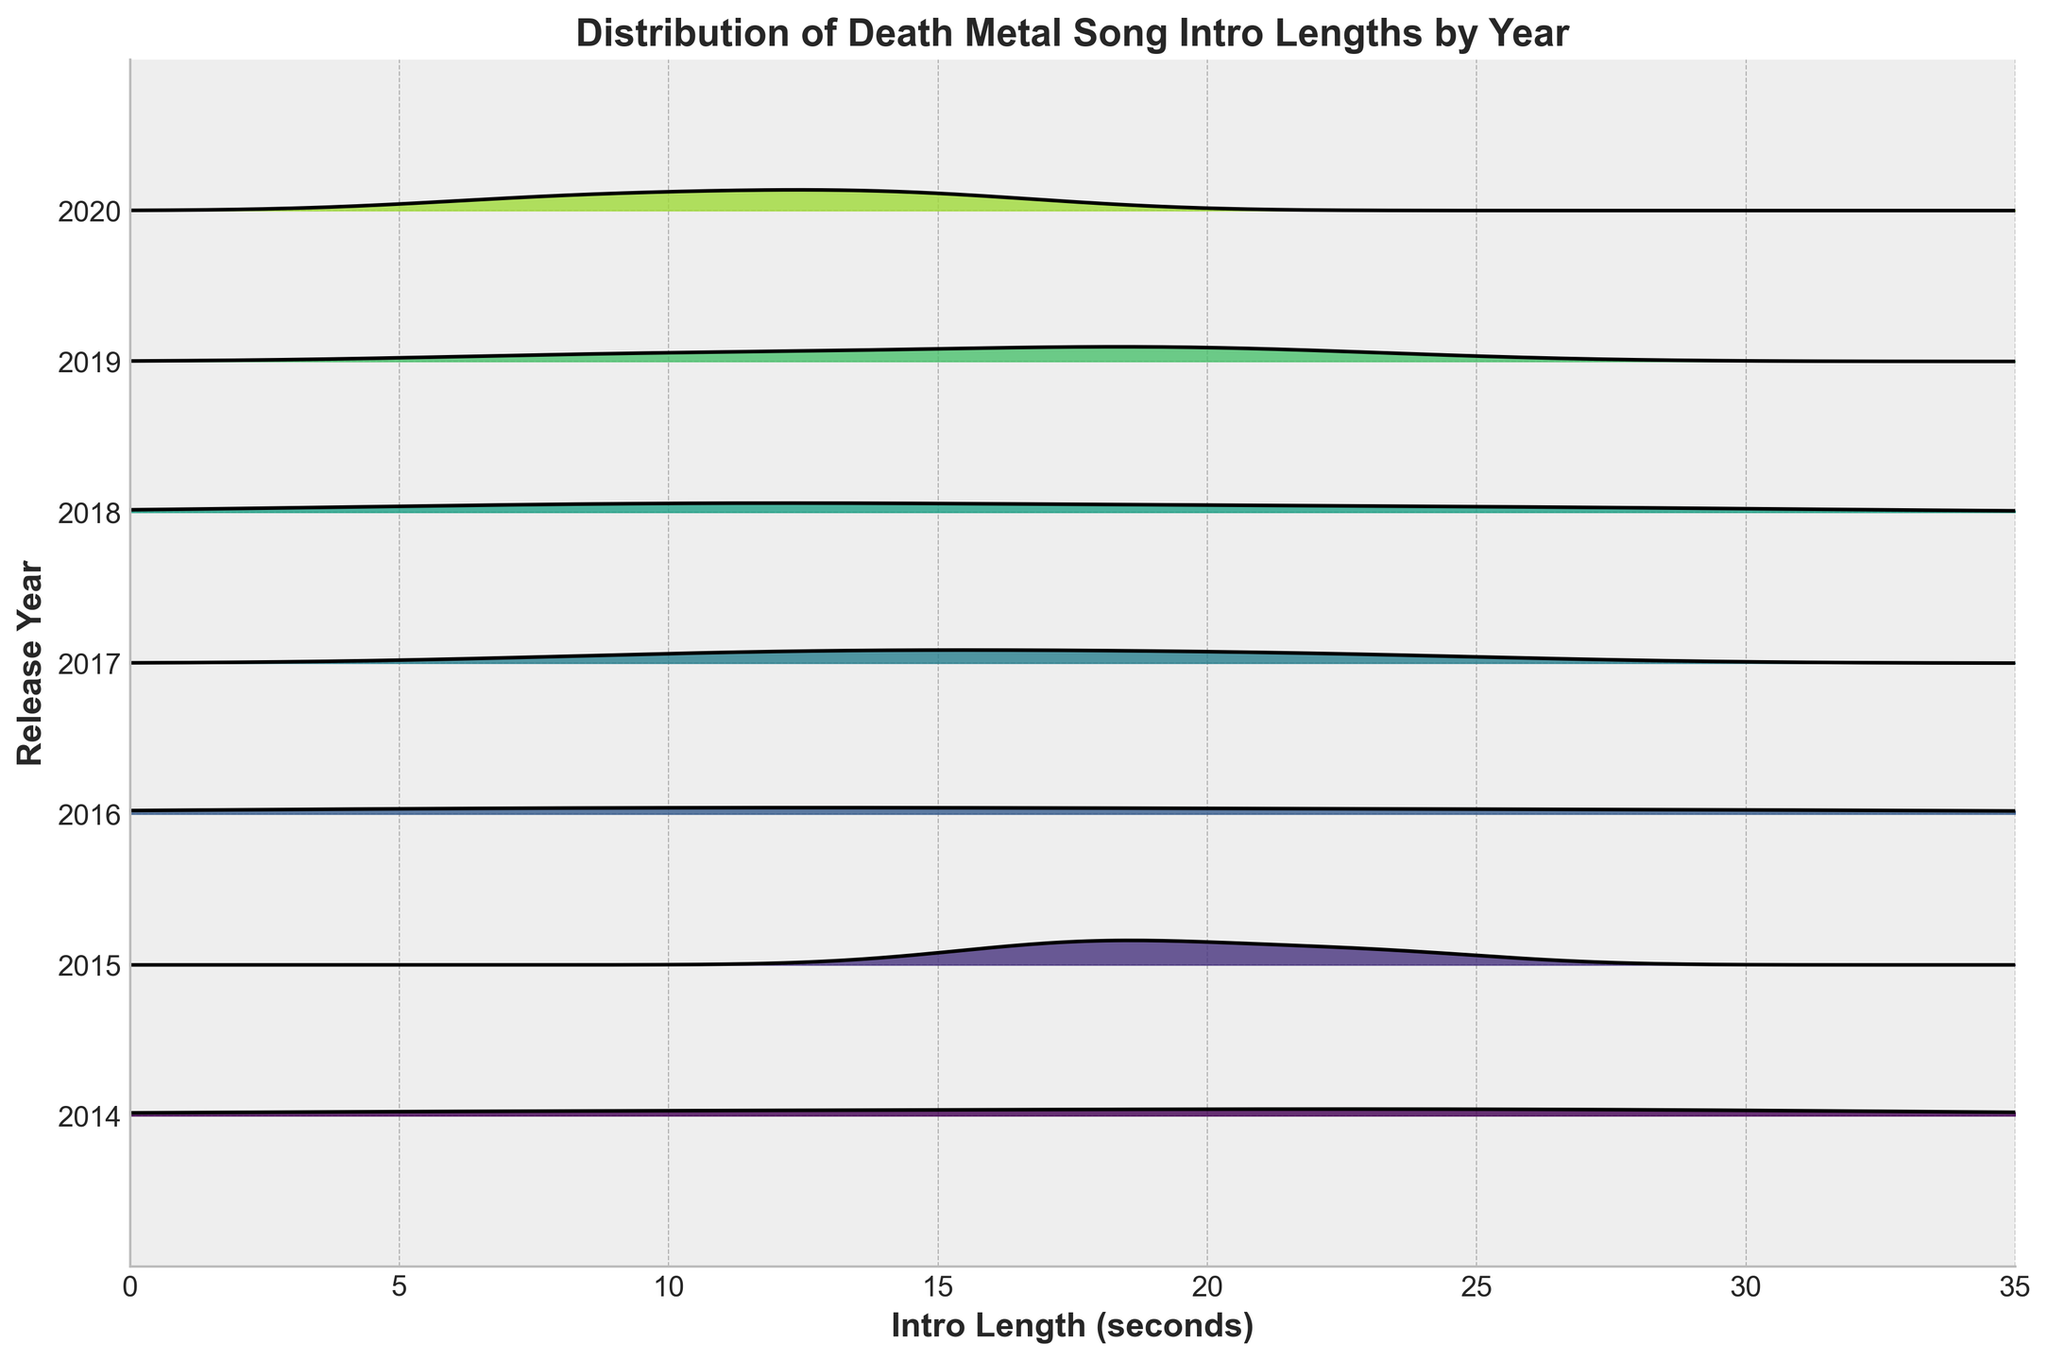What is the overall trend in intro lengths over the years? By examining the distribution for each year moving from 2014 to 2020, we can see if there is a tendency for intros to become longer or shorter. In 2016, for example, there seems to be a peak around 30 seconds, which is higher than the peaks in 2014 and 2015. However, the peaks in 2019 and 2020 seem to be lower, indicating shorter intros.
Answer: The overall trend shows fluctuation with no clear linear increase or decrease Which year had the longest song intro and what is its length? Looking at the peaks of each distribution, the year 2016 has the longest intro peak with a value of around 30 seconds.
Answer: 2016, 30 seconds Which years have the most and least varied intro lengths? Variation can be inferred by looking at the spread of the KDE curves. A wider and flatter curve suggests more variation. For instance, 2016 appears to have a wide spread, while 2020 shows a narrower one.
Answer: 2016 has the most varied and 2020 has the least varied Are there any years where intro lengths appear to have a consistent value? Consistency can be identified by looking for narrow peaks close to a specific intro length. For example, 2020 shows peaks around 8 to 15 seconds, indicating more consistency.
Answer: Yes, 2020 shows consistent intro lengths around 8 to 15 seconds How do the intro lengths from 2018 compare to those from 2014? By comparing the KDE curves of 2014 and 2018, we can note that 2014 has a peak around 28 seconds and smaller values closer to 6 seconds. In contrast, 2018 shows more spread with a noticeable peak around 25 seconds.
Answer: 2018 has more spread, while 2014 has peaks at the lower and higher ends What is the most common intro length in 2017? The peak of the KDE curve for 2017 will show the most common intro length. The highest peak appears around 22 seconds.
Answer: 22 seconds Which year shows the most significant drop or rise in intro length compared to its previous year? To identify this, compare the KDE peaks and spread year-over-year. A notable drop is seen from 2016 (30 seconds) to 2017 (22 seconds).
Answer: The most significant drop is from 2016 to 2017 Is there a correlation between the year and the length of song intros? If later years consistently showed longer or shorter intro lengths, that would indicate a trend. From the visual inspection, intro lengths do not show a clear, consistent correlation with the year of release.
Answer: No clear correlation Looking at the overall distribution, which intro length appears most frequently across all years? By observing where KDE peaks commonly align across different years, it seems the peaks around 15 to 22 seconds are frequent.
Answer: 15 to 22 seconds When was the peak year for the longest death metal song intros? The highest peak across the years on the KDE distribution indicates the longest intros. 2016 stands out prominently with intros peaking at around 30 seconds.
Answer: 2016 